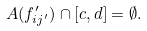Convert formula to latex. <formula><loc_0><loc_0><loc_500><loc_500>A ( f _ { i j ^ { \prime } } ^ { \prime } ) \cap [ c , d ] = \emptyset .</formula> 